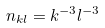<formula> <loc_0><loc_0><loc_500><loc_500>n _ { k l } = k ^ { - 3 } l ^ { - 3 }</formula> 